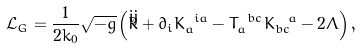<formula> <loc_0><loc_0><loc_500><loc_500>\mathcal { L } _ { G } = \frac { 1 } { 2 k _ { 0 } } \sqrt { - g } \left ( \mathring { R } + \partial _ { i } K _ { a } ^ { \text { \ } i a } - T _ { a } ^ { \text { \ } b c } K _ { b c } ^ { \text { \ \ } a } - 2 \Lambda \right ) ,</formula> 